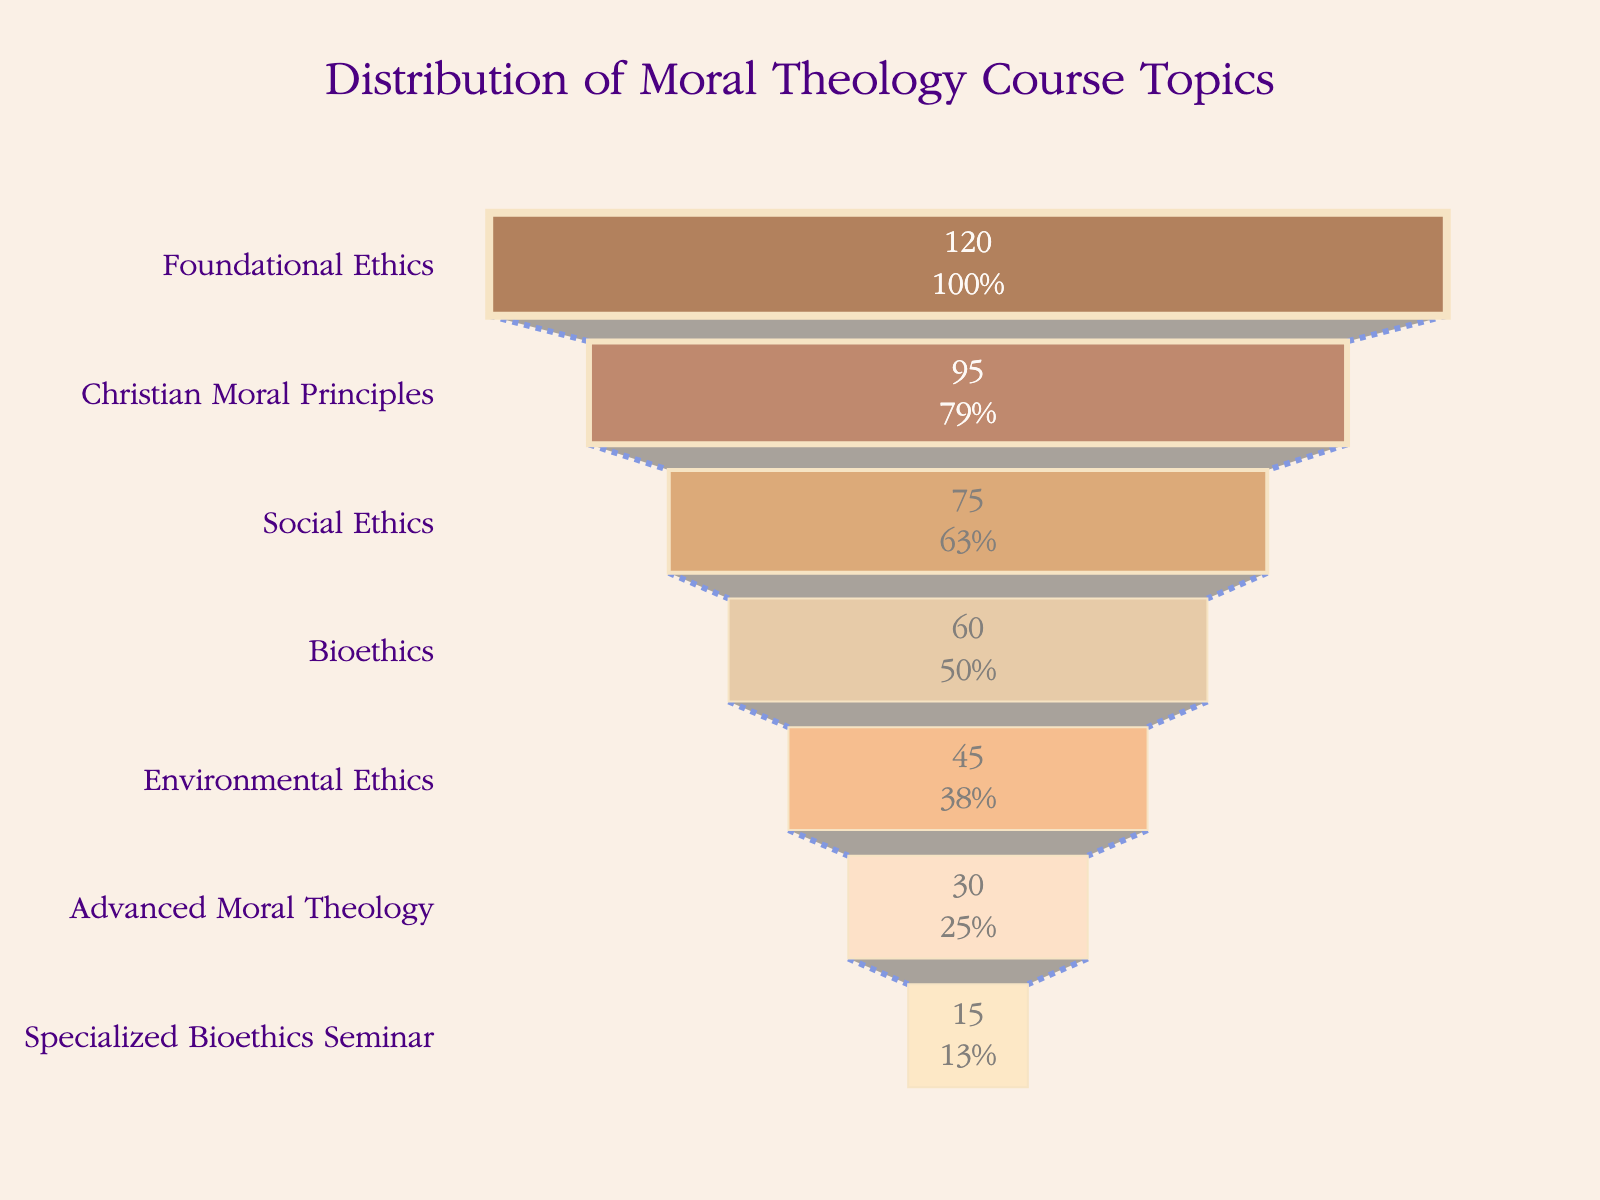What's the title of the funnel chart? The title of the chart is displayed at the top and it reads "Distribution of Moral Theology Course Topics".
Answer: Distribution of Moral Theology Course Topics Which course has the highest number of students? The course with the highest number of students is at the widest part of the funnel. It is "Foundational Ethics" with 120 students.
Answer: Foundational Ethics How many students are enrolled in the "Advanced Moral Theology" course? By looking at the funnel segment labeled "Advanced Moral Theology", we can see the number of students inside this section is 30.
Answer: 30 What percentage of students are enrolled in "Bioethics" compared to "Foundational Ethics"? To find the percentage, divide the number of students in "Bioethics" by the number of students in "Foundational Ethics" and multiply by 100: (60/120) * 100.
Answer: 50% How many more students are there in "Social Ethics" compared to "Specialized Bioethics Seminar"? Subtract the number of students in "Specialized Bioethics Seminar" from the number of students in "Social Ethics": 75 - 15.
Answer: 60 Which course has the smallest proportion of students? The smallest proportion of students can be found at the narrowest part of the funnel corresponding to "Specialized Bioethics Seminar".
Answer: Specialized Bioethics Seminar What is the total number of students across all course topics? Sum the number of students in all courses: 120 + 95 + 75 + 60 + 45 + 30 + 15.
Answer: 440 What is the difference in student numbers between "Christian Moral Principles" and "Environmental Ethics"? Subtract the number of students in "Environmental Ethics" from the number of students in "Christian Moral Principles": 95 - 45.
Answer: 50 Which two courses have the closest number of students? By examining the student numbers, "Bioethics" (60 students) and "Environmental Ethics" (45 students) have the closest number with a difference of 15 students.
Answer: Bioethics and Environmental Ethics How does the student distribution change as we go from the top to the bottom of the funnel? The student distribution decreases progressively, starting with 120 in "Foundational Ethics" and ending with 15 in "Specialized Bioethics Seminar".
Answer: It decreases 